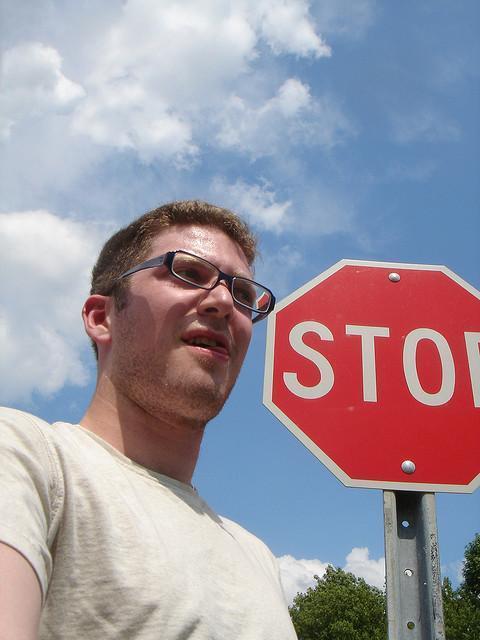How many rolls of toilet paper are on the wall?
Give a very brief answer. 0. 